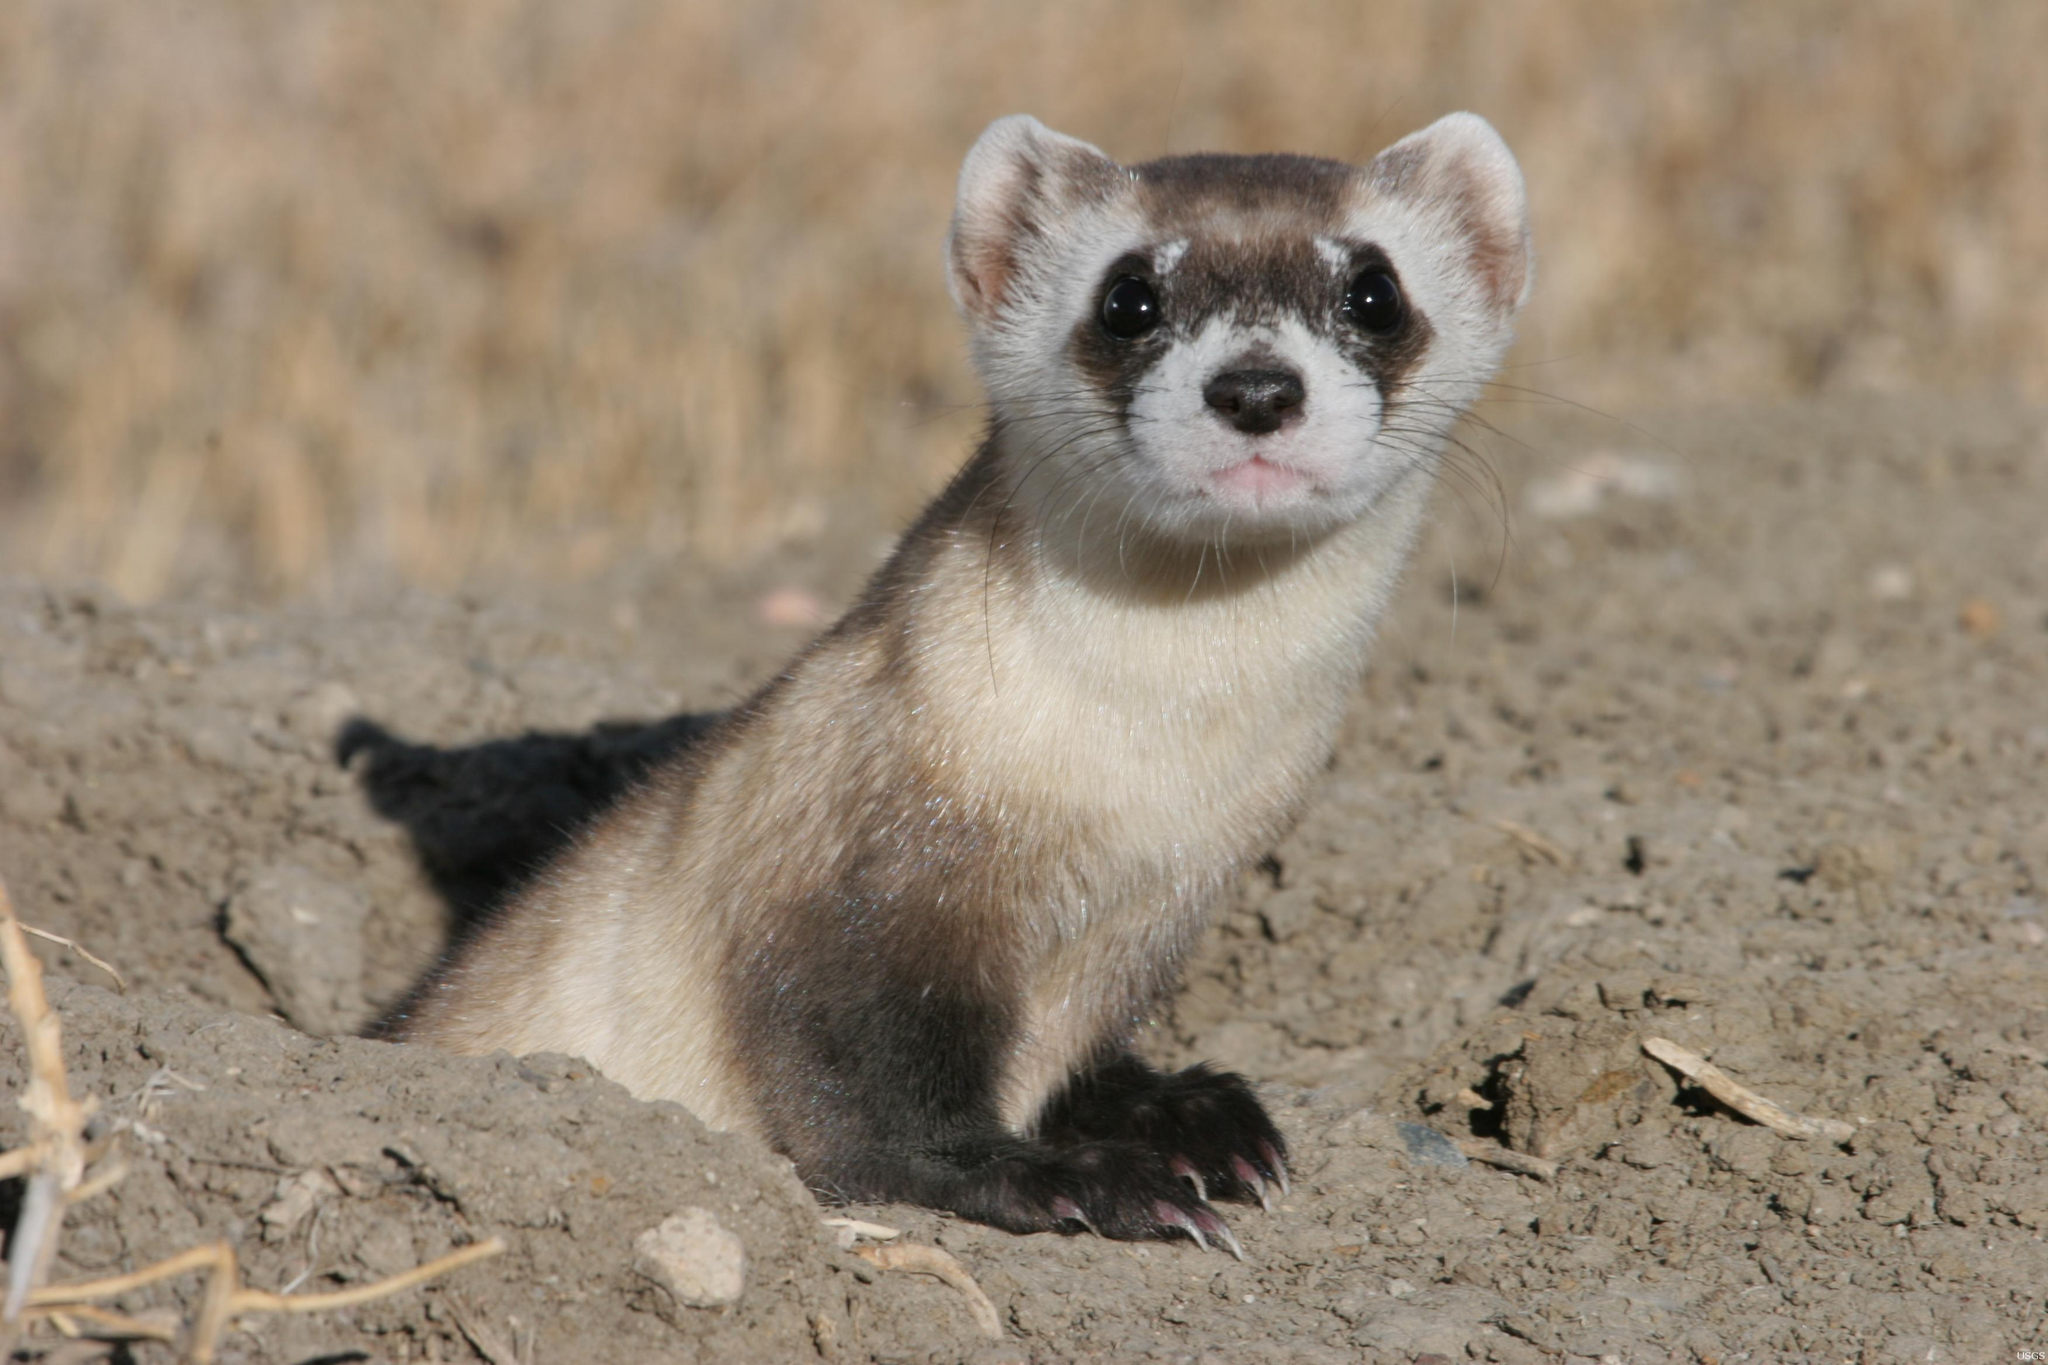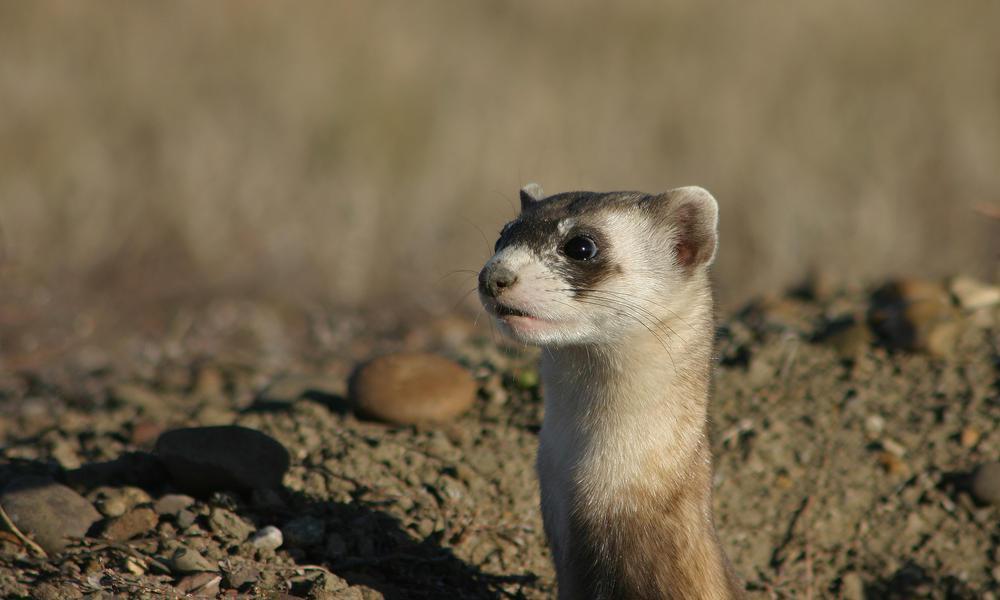The first image is the image on the left, the second image is the image on the right. Given the left and right images, does the statement "Each image contains one ferret, and no ferrets are emerging from a hole in the ground." hold true? Answer yes or no. No. The first image is the image on the left, the second image is the image on the right. Assess this claim about the two images: "An image contains a prairie dog coming out of a hole.". Correct or not? Answer yes or no. Yes. 